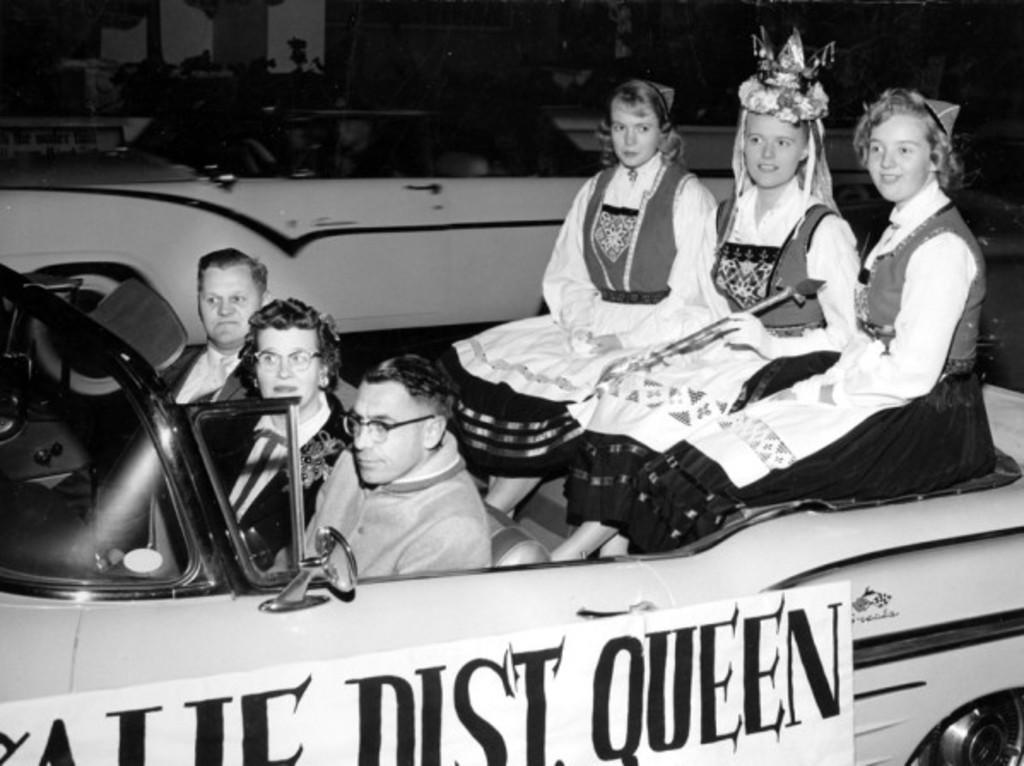Please provide a concise description of this image. There are group of people sitting on the car and riding and there is a poster stick on car showing the dust queen. 